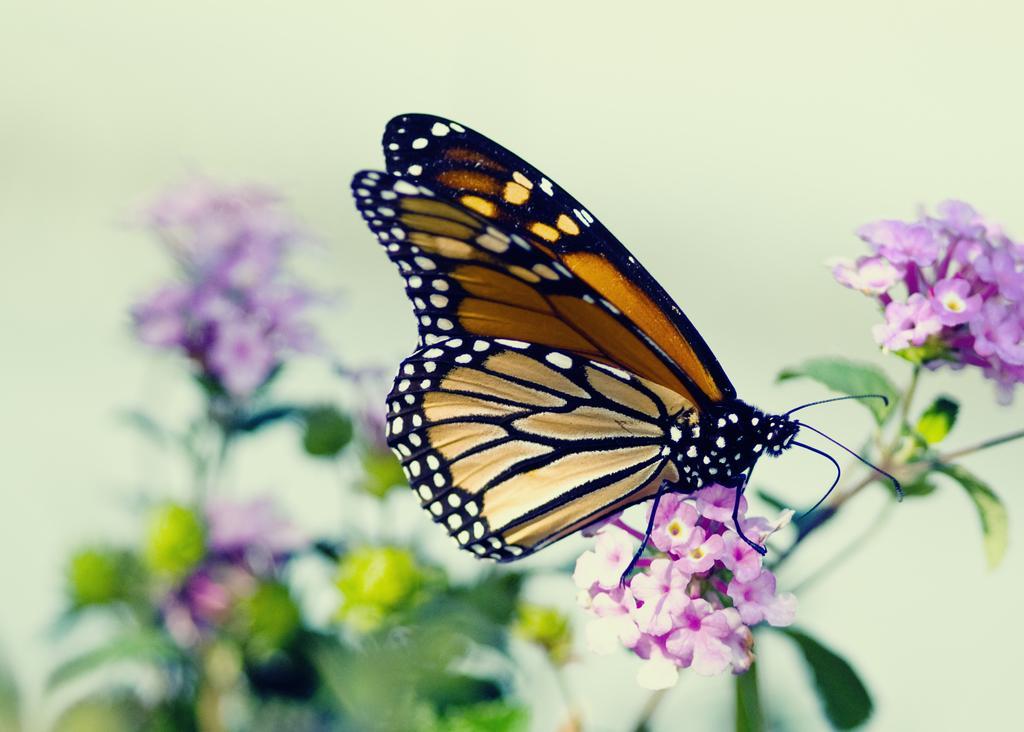In one or two sentences, can you explain what this image depicts? In this image, we can see a butterfly on the flowers. Background we can see the blur view. Here we can see flowers, stems and leaves. 